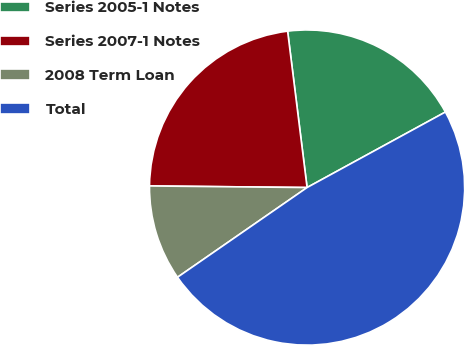Convert chart to OTSL. <chart><loc_0><loc_0><loc_500><loc_500><pie_chart><fcel>Series 2005-1 Notes<fcel>Series 2007-1 Notes<fcel>2008 Term Loan<fcel>Total<nl><fcel>19.02%<fcel>22.87%<fcel>9.8%<fcel>48.32%<nl></chart> 